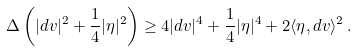<formula> <loc_0><loc_0><loc_500><loc_500>\Delta \left ( | d v | ^ { 2 } + \frac { 1 } { 4 } | \eta | ^ { 2 } \right ) \geq 4 | d v | ^ { 4 } + \frac { 1 } { 4 } | \eta | ^ { 4 } + 2 \langle \eta , d v \rangle ^ { 2 } \, .</formula> 